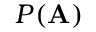Convert formula to latex. <formula><loc_0><loc_0><loc_500><loc_500>P ( A )</formula> 